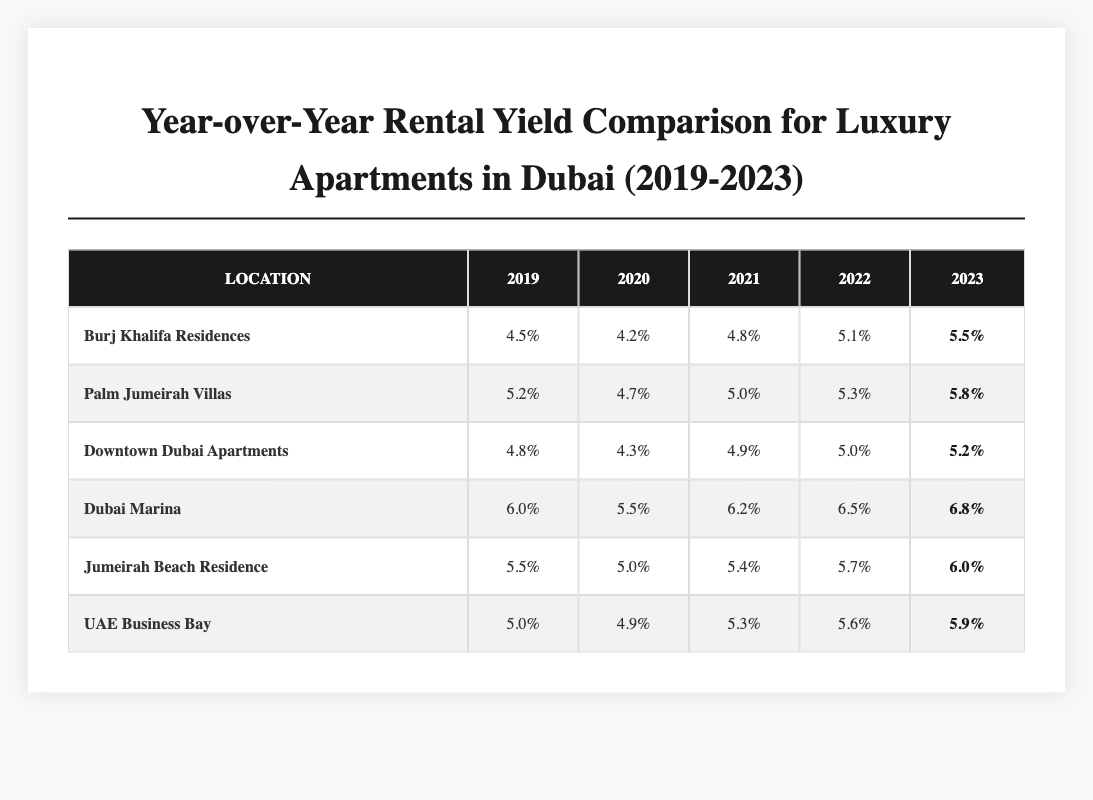What was the highest rental yield in Dubai Marina from 2019 to 2023? According to the table, the rental yield in Dubai Marina for 2023 was 6.8%, which is the highest compared to previous years: 6.0% in 2019, 5.5% in 2020, 6.2% in 2021, and 6.5% in 2022.
Answer: 6.8% Which apartment location showed a continuous increase in rental yield from 2019 to 2023? In the table, Dubai Marina shows a continuous increase in rental yield each year: 6.0% in 2019, 5.5% in 2020, 6.2% in 2021, 6.5% in 2022, and 6.8% in 2023.
Answer: Yes What was the average rental yield for Jumeirah Beach Residence over the years? To find the average, sum the yields: 5.5% + 5.0% + 5.4% + 5.7% + 6.0% = 27.6%. There are 5 years, so the average is 27.6% / 5 = 5.52%.
Answer: 5.52% How much did the rental yield of Burj Khalifa Residences increase from 2019 to 2023? The rental yield increased from 4.5% in 2019 to 5.5% in 2023. The increase is 5.5% - 4.5% = 1.0%.
Answer: 1.0% What was the lowest rental yield recorded in Palm Jumeirah Villas? In the table, Palm Jumeirah Villas had a lowest yield of 4.7% in 2020, as this is the lowest figure present among the recorded years.
Answer: 4.7% In which year did Downtown Dubai Apartments see its maximum rental yield? The maximum rental yield for Downtown Dubai Apartments was 5.2%, which occurred in 2023. Checking the figures for that location, 4.8% in 2019, 4.3% in 2020, 4.9% in 2021, and 5.0% in 2022 confirm this.
Answer: 2023 How does the 2023 rental yield for UAE Business Bay compare to that of 2019? The rental yield for UAE Business Bay in 2023 is 5.9%, while in 2019, it was 5.0%. The difference is 5.9% - 5.0% = 0.9%, indicating an increase.
Answer: It increased by 0.9% Which apartment has the lowest rental yield in 2022? From the table, the lowest rental yield in 2022 is for Palm Jumeirah Villas at 5.3%, compared to the other figures for that year.
Answer: Palm Jumeirah Villas What is the total rental yield for all locations in 2023? First, we sum the rental yields for all locations in 2023: 5.5% (Burj Khalifa) + 5.8% (Palm Jumeirah) + 5.2% (Downtown Dubai) + 6.8% (Dubai Marina) + 6.0% (Jumeirah Beach) + 5.9% (UAE Business Bay) = 35.2%.
Answer: 35.2% Which location had the highest rental yield in 2023 compared to other locations? The highest rental yield in 2023 is 6.8% for Dubai Marina, higher than any other location's yield for that year.
Answer: Dubai Marina What was the percentage increase in rental yield for Jumeirah Beach Residence from 2019 to 2023? Jumeirah Beach Residence increased from 5.5% in 2019 to 6.0% in 2023, resulting in an increase of 6.0% - 5.5% = 0.5%.
Answer: 0.5% 